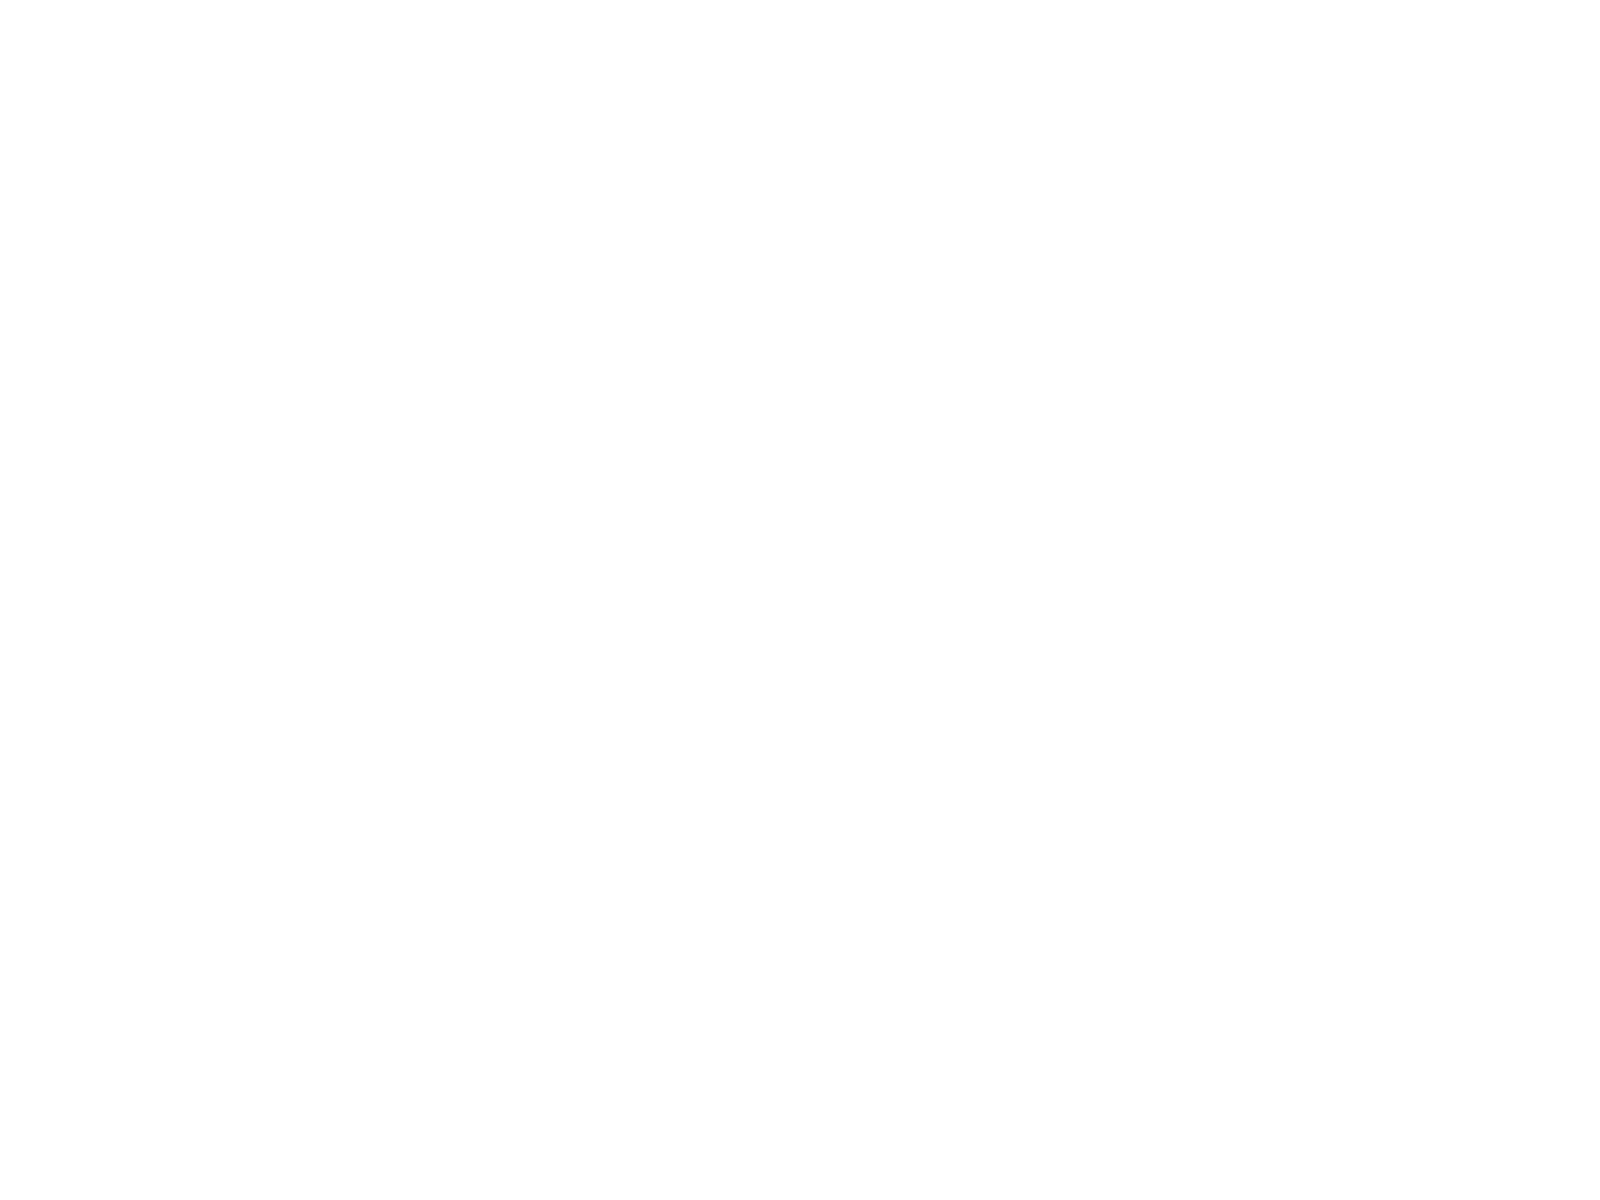Convert chart to OTSL. <chart><loc_0><loc_0><loc_500><loc_500><pie_chart><fcel>Net Sales<fcel>Marketing<fcel>Research & Development<fcel>Income from Operations (2)<fcel>of Sales<fcel>Net Income (23)<fcel>Net Income per Share-Basic<fcel>Net Income per Share-Diluted<fcel>Total Assets<fcel>Total Debt<nl><fcel>16.48%<fcel>12.09%<fcel>8.79%<fcel>13.19%<fcel>3.3%<fcel>10.99%<fcel>2.2%<fcel>1.1%<fcel>17.58%<fcel>14.29%<nl></chart> 